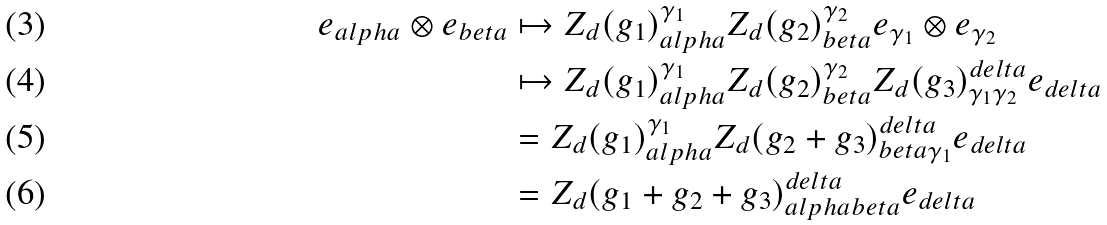<formula> <loc_0><loc_0><loc_500><loc_500>e _ { a l p h a } \otimes e _ { b e t a } & \mapsto Z _ { d } ( g _ { 1 } ) ^ { \gamma _ { 1 } } _ { a l p h a } Z _ { d } ( g _ { 2 } ) ^ { \gamma _ { 2 } } _ { b e t a } e _ { \gamma _ { 1 } } \otimes e _ { \gamma _ { 2 } } \\ & \mapsto Z _ { d } ( g _ { 1 } ) ^ { \gamma _ { 1 } } _ { a l p h a } Z _ { d } ( g _ { 2 } ) ^ { \gamma _ { 2 } } _ { b e t a } Z _ { d } ( g _ { 3 } ) ^ { d e l t a } _ { \gamma _ { 1 } \gamma _ { 2 } } e _ { d e l t a } \\ & = Z _ { d } ( g _ { 1 } ) ^ { \gamma _ { 1 } } _ { a l p h a } Z _ { d } ( g _ { 2 } + g _ { 3 } ) ^ { d e l t a } _ { b e t a \gamma _ { 1 } } e _ { d e l t a } \\ & = Z _ { d } ( g _ { 1 } + g _ { 2 } + g _ { 3 } ) ^ { d e l t a } _ { a l p h a b e t a } e _ { d e l t a }</formula> 